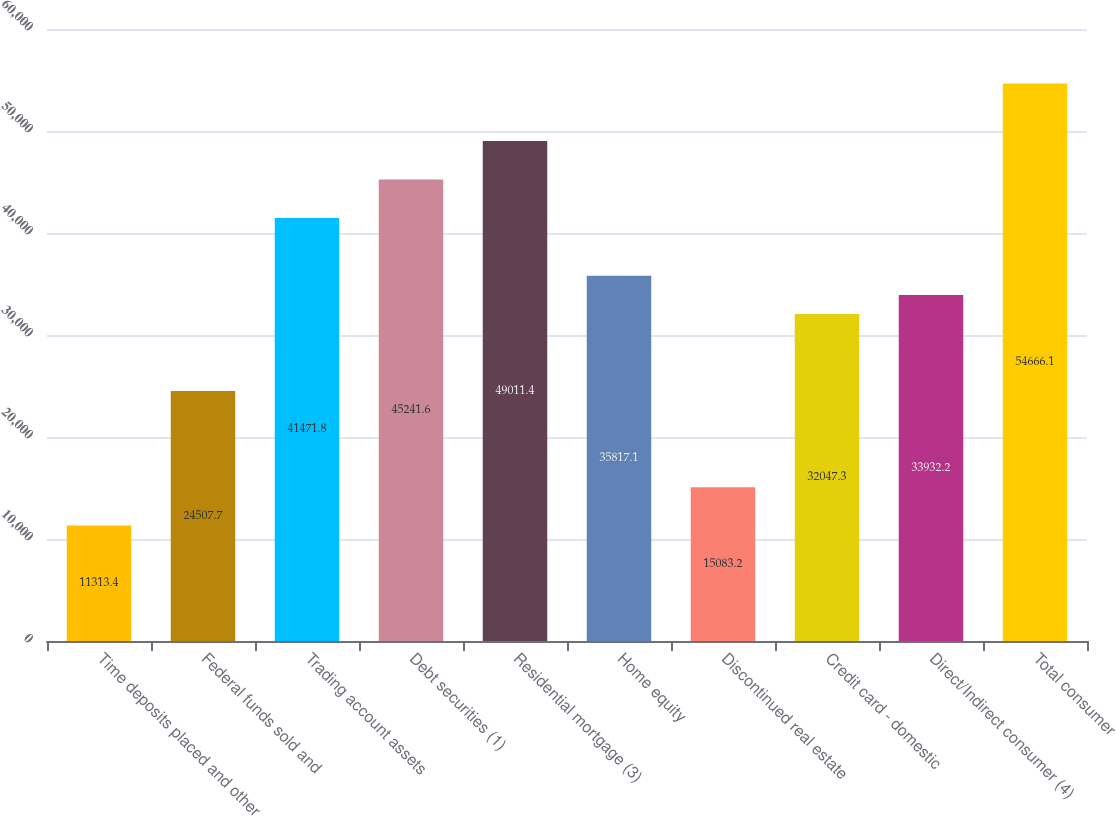Convert chart to OTSL. <chart><loc_0><loc_0><loc_500><loc_500><bar_chart><fcel>Time deposits placed and other<fcel>Federal funds sold and<fcel>Trading account assets<fcel>Debt securities (1)<fcel>Residential mortgage (3)<fcel>Home equity<fcel>Discontinued real estate<fcel>Credit card - domestic<fcel>Direct/Indirect consumer (4)<fcel>Total consumer<nl><fcel>11313.4<fcel>24507.7<fcel>41471.8<fcel>45241.6<fcel>49011.4<fcel>35817.1<fcel>15083.2<fcel>32047.3<fcel>33932.2<fcel>54666.1<nl></chart> 